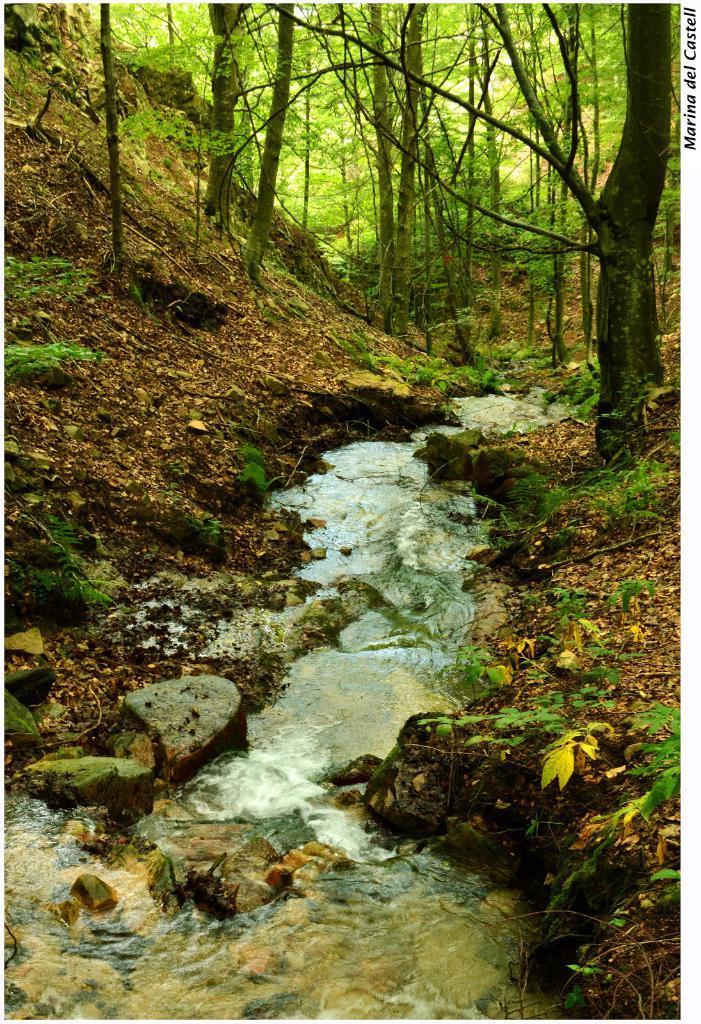In one or two sentences, can you explain what this image depicts? The given picture is taken in the forest. There are trees all around the place. This is some amount of water. These are some dry leaves. There are some plants. 